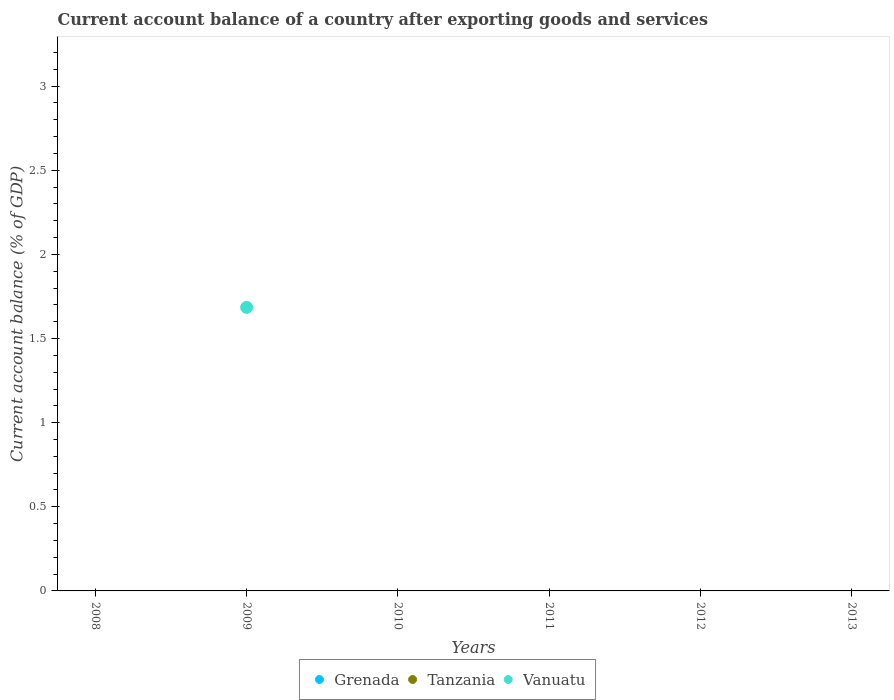How many different coloured dotlines are there?
Ensure brevity in your answer.  1. What is the account balance in Vanuatu in 2008?
Your answer should be compact. 0. Across all years, what is the maximum account balance in Vanuatu?
Your answer should be compact. 1.69. In which year was the account balance in Vanuatu maximum?
Your answer should be very brief. 2009. What is the total account balance in Tanzania in the graph?
Offer a very short reply. 0. What is the average account balance in Vanuatu per year?
Offer a very short reply. 0.28. What is the difference between the highest and the lowest account balance in Vanuatu?
Provide a succinct answer. 1.69. Does the account balance in Tanzania monotonically increase over the years?
Offer a very short reply. No. Is the account balance in Tanzania strictly greater than the account balance in Grenada over the years?
Offer a very short reply. Yes. Is the account balance in Vanuatu strictly less than the account balance in Grenada over the years?
Provide a succinct answer. No. What is the difference between two consecutive major ticks on the Y-axis?
Make the answer very short. 0.5. Are the values on the major ticks of Y-axis written in scientific E-notation?
Your answer should be very brief. No. Does the graph contain any zero values?
Your answer should be very brief. Yes. Does the graph contain grids?
Provide a succinct answer. No. How are the legend labels stacked?
Offer a terse response. Horizontal. What is the title of the graph?
Your answer should be very brief. Current account balance of a country after exporting goods and services. Does "Mongolia" appear as one of the legend labels in the graph?
Provide a short and direct response. No. What is the label or title of the Y-axis?
Provide a succinct answer. Current account balance (% of GDP). What is the Current account balance (% of GDP) of Grenada in 2008?
Offer a very short reply. 0. What is the Current account balance (% of GDP) of Tanzania in 2008?
Give a very brief answer. 0. What is the Current account balance (% of GDP) in Vanuatu in 2008?
Provide a short and direct response. 0. What is the Current account balance (% of GDP) of Grenada in 2009?
Provide a short and direct response. 0. What is the Current account balance (% of GDP) in Vanuatu in 2009?
Give a very brief answer. 1.69. What is the Current account balance (% of GDP) of Grenada in 2010?
Make the answer very short. 0. What is the Current account balance (% of GDP) of Vanuatu in 2010?
Your response must be concise. 0. What is the Current account balance (% of GDP) of Grenada in 2011?
Make the answer very short. 0. What is the Current account balance (% of GDP) of Tanzania in 2011?
Provide a succinct answer. 0. What is the Current account balance (% of GDP) of Grenada in 2012?
Provide a succinct answer. 0. What is the Current account balance (% of GDP) of Tanzania in 2012?
Your answer should be very brief. 0. What is the Current account balance (% of GDP) in Grenada in 2013?
Your answer should be compact. 0. Across all years, what is the maximum Current account balance (% of GDP) of Vanuatu?
Give a very brief answer. 1.69. What is the total Current account balance (% of GDP) of Vanuatu in the graph?
Offer a terse response. 1.69. What is the average Current account balance (% of GDP) of Vanuatu per year?
Ensure brevity in your answer.  0.28. What is the difference between the highest and the lowest Current account balance (% of GDP) of Vanuatu?
Provide a succinct answer. 1.69. 